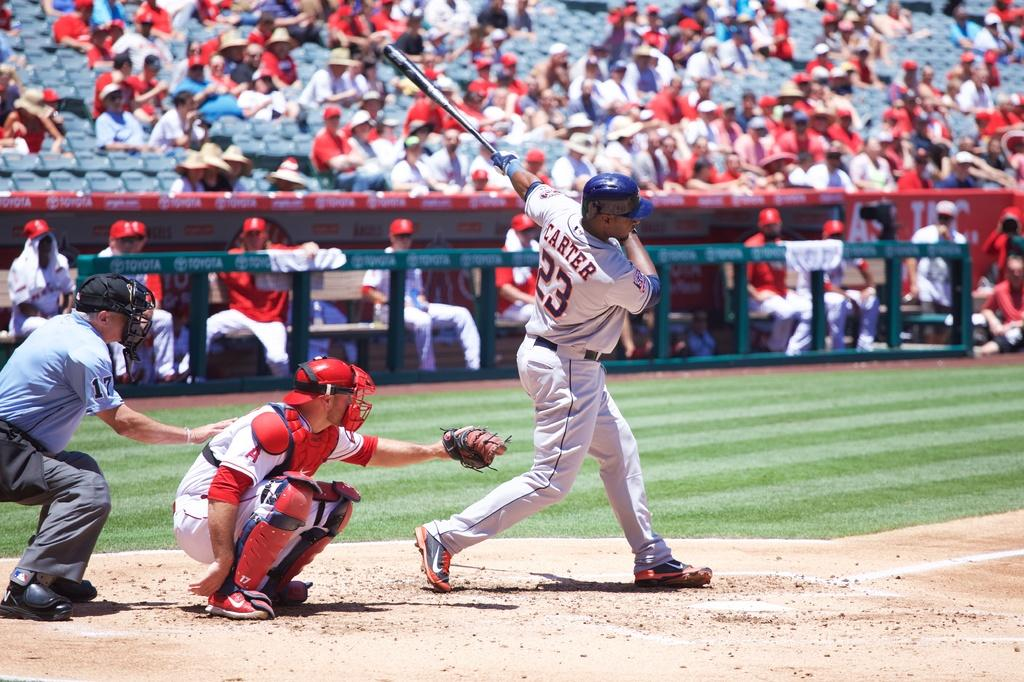<image>
Present a compact description of the photo's key features. A baseball player whose uniform says Carter is swinging at the ball. 